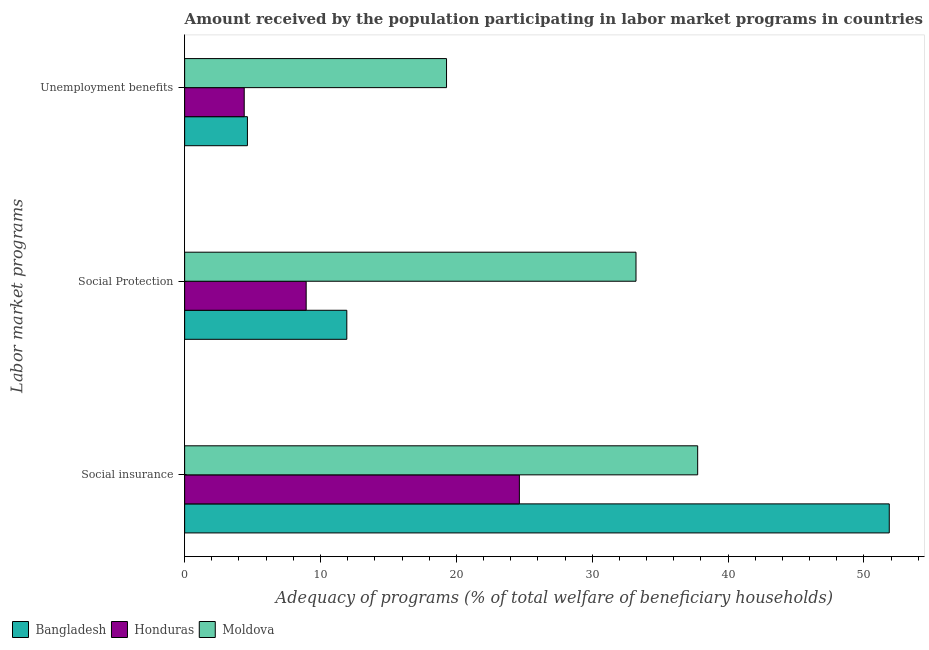How many different coloured bars are there?
Your answer should be compact. 3. Are the number of bars per tick equal to the number of legend labels?
Give a very brief answer. Yes. What is the label of the 2nd group of bars from the top?
Make the answer very short. Social Protection. What is the amount received by the population participating in social insurance programs in Moldova?
Your answer should be compact. 37.76. Across all countries, what is the maximum amount received by the population participating in unemployment benefits programs?
Provide a succinct answer. 19.28. Across all countries, what is the minimum amount received by the population participating in social insurance programs?
Your answer should be very brief. 24.64. In which country was the amount received by the population participating in social protection programs maximum?
Provide a succinct answer. Moldova. In which country was the amount received by the population participating in unemployment benefits programs minimum?
Offer a very short reply. Honduras. What is the total amount received by the population participating in social insurance programs in the graph?
Provide a succinct answer. 114.26. What is the difference between the amount received by the population participating in unemployment benefits programs in Bangladesh and that in Moldova?
Your answer should be very brief. -14.66. What is the difference between the amount received by the population participating in unemployment benefits programs in Honduras and the amount received by the population participating in social protection programs in Bangladesh?
Offer a very short reply. -7.55. What is the average amount received by the population participating in unemployment benefits programs per country?
Offer a terse response. 9.43. What is the difference between the amount received by the population participating in social insurance programs and amount received by the population participating in social protection programs in Moldova?
Provide a succinct answer. 4.54. In how many countries, is the amount received by the population participating in unemployment benefits programs greater than 38 %?
Give a very brief answer. 0. What is the ratio of the amount received by the population participating in unemployment benefits programs in Bangladesh to that in Honduras?
Provide a succinct answer. 1.05. Is the amount received by the population participating in unemployment benefits programs in Honduras less than that in Bangladesh?
Your response must be concise. Yes. Is the difference between the amount received by the population participating in unemployment benefits programs in Bangladesh and Moldova greater than the difference between the amount received by the population participating in social protection programs in Bangladesh and Moldova?
Provide a short and direct response. Yes. What is the difference between the highest and the second highest amount received by the population participating in social protection programs?
Keep it short and to the point. 21.28. What is the difference between the highest and the lowest amount received by the population participating in social insurance programs?
Provide a short and direct response. 27.22. Is it the case that in every country, the sum of the amount received by the population participating in social insurance programs and amount received by the population participating in social protection programs is greater than the amount received by the population participating in unemployment benefits programs?
Keep it short and to the point. Yes. How many bars are there?
Offer a terse response. 9. What is the difference between two consecutive major ticks on the X-axis?
Offer a terse response. 10. Are the values on the major ticks of X-axis written in scientific E-notation?
Offer a very short reply. No. Does the graph contain any zero values?
Your answer should be very brief. No. Where does the legend appear in the graph?
Offer a very short reply. Bottom left. How many legend labels are there?
Make the answer very short. 3. How are the legend labels stacked?
Provide a short and direct response. Horizontal. What is the title of the graph?
Ensure brevity in your answer.  Amount received by the population participating in labor market programs in countries. What is the label or title of the X-axis?
Keep it short and to the point. Adequacy of programs (% of total welfare of beneficiary households). What is the label or title of the Y-axis?
Offer a terse response. Labor market programs. What is the Adequacy of programs (% of total welfare of beneficiary households) in Bangladesh in Social insurance?
Provide a short and direct response. 51.86. What is the Adequacy of programs (% of total welfare of beneficiary households) in Honduras in Social insurance?
Offer a very short reply. 24.64. What is the Adequacy of programs (% of total welfare of beneficiary households) in Moldova in Social insurance?
Provide a short and direct response. 37.76. What is the Adequacy of programs (% of total welfare of beneficiary households) of Bangladesh in Social Protection?
Your answer should be compact. 11.94. What is the Adequacy of programs (% of total welfare of beneficiary households) in Honduras in Social Protection?
Provide a short and direct response. 8.94. What is the Adequacy of programs (% of total welfare of beneficiary households) of Moldova in Social Protection?
Offer a terse response. 33.22. What is the Adequacy of programs (% of total welfare of beneficiary households) in Bangladesh in Unemployment benefits?
Your response must be concise. 4.62. What is the Adequacy of programs (% of total welfare of beneficiary households) of Honduras in Unemployment benefits?
Make the answer very short. 4.39. What is the Adequacy of programs (% of total welfare of beneficiary households) of Moldova in Unemployment benefits?
Provide a succinct answer. 19.28. Across all Labor market programs, what is the maximum Adequacy of programs (% of total welfare of beneficiary households) in Bangladesh?
Give a very brief answer. 51.86. Across all Labor market programs, what is the maximum Adequacy of programs (% of total welfare of beneficiary households) of Honduras?
Offer a very short reply. 24.64. Across all Labor market programs, what is the maximum Adequacy of programs (% of total welfare of beneficiary households) of Moldova?
Ensure brevity in your answer.  37.76. Across all Labor market programs, what is the minimum Adequacy of programs (% of total welfare of beneficiary households) of Bangladesh?
Ensure brevity in your answer.  4.62. Across all Labor market programs, what is the minimum Adequacy of programs (% of total welfare of beneficiary households) in Honduras?
Your response must be concise. 4.39. Across all Labor market programs, what is the minimum Adequacy of programs (% of total welfare of beneficiary households) of Moldova?
Ensure brevity in your answer.  19.28. What is the total Adequacy of programs (% of total welfare of beneficiary households) of Bangladesh in the graph?
Your response must be concise. 68.42. What is the total Adequacy of programs (% of total welfare of beneficiary households) in Honduras in the graph?
Keep it short and to the point. 37.97. What is the total Adequacy of programs (% of total welfare of beneficiary households) in Moldova in the graph?
Keep it short and to the point. 90.26. What is the difference between the Adequacy of programs (% of total welfare of beneficiary households) of Bangladesh in Social insurance and that in Social Protection?
Provide a succinct answer. 39.92. What is the difference between the Adequacy of programs (% of total welfare of beneficiary households) of Honduras in Social insurance and that in Social Protection?
Your response must be concise. 15.69. What is the difference between the Adequacy of programs (% of total welfare of beneficiary households) in Moldova in Social insurance and that in Social Protection?
Provide a succinct answer. 4.54. What is the difference between the Adequacy of programs (% of total welfare of beneficiary households) in Bangladesh in Social insurance and that in Unemployment benefits?
Ensure brevity in your answer.  47.24. What is the difference between the Adequacy of programs (% of total welfare of beneficiary households) of Honduras in Social insurance and that in Unemployment benefits?
Offer a very short reply. 20.25. What is the difference between the Adequacy of programs (% of total welfare of beneficiary households) in Moldova in Social insurance and that in Unemployment benefits?
Provide a short and direct response. 18.48. What is the difference between the Adequacy of programs (% of total welfare of beneficiary households) of Bangladesh in Social Protection and that in Unemployment benefits?
Ensure brevity in your answer.  7.32. What is the difference between the Adequacy of programs (% of total welfare of beneficiary households) of Honduras in Social Protection and that in Unemployment benefits?
Offer a very short reply. 4.56. What is the difference between the Adequacy of programs (% of total welfare of beneficiary households) in Moldova in Social Protection and that in Unemployment benefits?
Make the answer very short. 13.95. What is the difference between the Adequacy of programs (% of total welfare of beneficiary households) in Bangladesh in Social insurance and the Adequacy of programs (% of total welfare of beneficiary households) in Honduras in Social Protection?
Your response must be concise. 42.92. What is the difference between the Adequacy of programs (% of total welfare of beneficiary households) in Bangladesh in Social insurance and the Adequacy of programs (% of total welfare of beneficiary households) in Moldova in Social Protection?
Provide a succinct answer. 18.64. What is the difference between the Adequacy of programs (% of total welfare of beneficiary households) in Honduras in Social insurance and the Adequacy of programs (% of total welfare of beneficiary households) in Moldova in Social Protection?
Ensure brevity in your answer.  -8.58. What is the difference between the Adequacy of programs (% of total welfare of beneficiary households) of Bangladesh in Social insurance and the Adequacy of programs (% of total welfare of beneficiary households) of Honduras in Unemployment benefits?
Offer a terse response. 47.48. What is the difference between the Adequacy of programs (% of total welfare of beneficiary households) in Bangladesh in Social insurance and the Adequacy of programs (% of total welfare of beneficiary households) in Moldova in Unemployment benefits?
Your answer should be very brief. 32.59. What is the difference between the Adequacy of programs (% of total welfare of beneficiary households) of Honduras in Social insurance and the Adequacy of programs (% of total welfare of beneficiary households) of Moldova in Unemployment benefits?
Your response must be concise. 5.36. What is the difference between the Adequacy of programs (% of total welfare of beneficiary households) of Bangladesh in Social Protection and the Adequacy of programs (% of total welfare of beneficiary households) of Honduras in Unemployment benefits?
Offer a very short reply. 7.55. What is the difference between the Adequacy of programs (% of total welfare of beneficiary households) of Bangladesh in Social Protection and the Adequacy of programs (% of total welfare of beneficiary households) of Moldova in Unemployment benefits?
Your answer should be compact. -7.34. What is the difference between the Adequacy of programs (% of total welfare of beneficiary households) in Honduras in Social Protection and the Adequacy of programs (% of total welfare of beneficiary households) in Moldova in Unemployment benefits?
Give a very brief answer. -10.33. What is the average Adequacy of programs (% of total welfare of beneficiary households) in Bangladesh per Labor market programs?
Provide a succinct answer. 22.81. What is the average Adequacy of programs (% of total welfare of beneficiary households) of Honduras per Labor market programs?
Keep it short and to the point. 12.66. What is the average Adequacy of programs (% of total welfare of beneficiary households) of Moldova per Labor market programs?
Give a very brief answer. 30.09. What is the difference between the Adequacy of programs (% of total welfare of beneficiary households) of Bangladesh and Adequacy of programs (% of total welfare of beneficiary households) of Honduras in Social insurance?
Provide a succinct answer. 27.22. What is the difference between the Adequacy of programs (% of total welfare of beneficiary households) of Bangladesh and Adequacy of programs (% of total welfare of beneficiary households) of Moldova in Social insurance?
Your response must be concise. 14.1. What is the difference between the Adequacy of programs (% of total welfare of beneficiary households) in Honduras and Adequacy of programs (% of total welfare of beneficiary households) in Moldova in Social insurance?
Provide a short and direct response. -13.12. What is the difference between the Adequacy of programs (% of total welfare of beneficiary households) in Bangladesh and Adequacy of programs (% of total welfare of beneficiary households) in Honduras in Social Protection?
Offer a very short reply. 2.99. What is the difference between the Adequacy of programs (% of total welfare of beneficiary households) of Bangladesh and Adequacy of programs (% of total welfare of beneficiary households) of Moldova in Social Protection?
Keep it short and to the point. -21.28. What is the difference between the Adequacy of programs (% of total welfare of beneficiary households) of Honduras and Adequacy of programs (% of total welfare of beneficiary households) of Moldova in Social Protection?
Make the answer very short. -24.28. What is the difference between the Adequacy of programs (% of total welfare of beneficiary households) of Bangladesh and Adequacy of programs (% of total welfare of beneficiary households) of Honduras in Unemployment benefits?
Offer a very short reply. 0.23. What is the difference between the Adequacy of programs (% of total welfare of beneficiary households) in Bangladesh and Adequacy of programs (% of total welfare of beneficiary households) in Moldova in Unemployment benefits?
Your answer should be compact. -14.66. What is the difference between the Adequacy of programs (% of total welfare of beneficiary households) in Honduras and Adequacy of programs (% of total welfare of beneficiary households) in Moldova in Unemployment benefits?
Ensure brevity in your answer.  -14.89. What is the ratio of the Adequacy of programs (% of total welfare of beneficiary households) in Bangladesh in Social insurance to that in Social Protection?
Offer a terse response. 4.34. What is the ratio of the Adequacy of programs (% of total welfare of beneficiary households) in Honduras in Social insurance to that in Social Protection?
Give a very brief answer. 2.75. What is the ratio of the Adequacy of programs (% of total welfare of beneficiary households) of Moldova in Social insurance to that in Social Protection?
Your answer should be very brief. 1.14. What is the ratio of the Adequacy of programs (% of total welfare of beneficiary households) of Bangladesh in Social insurance to that in Unemployment benefits?
Give a very brief answer. 11.22. What is the ratio of the Adequacy of programs (% of total welfare of beneficiary households) in Honduras in Social insurance to that in Unemployment benefits?
Your response must be concise. 5.62. What is the ratio of the Adequacy of programs (% of total welfare of beneficiary households) of Moldova in Social insurance to that in Unemployment benefits?
Provide a short and direct response. 1.96. What is the ratio of the Adequacy of programs (% of total welfare of beneficiary households) of Bangladesh in Social Protection to that in Unemployment benefits?
Ensure brevity in your answer.  2.58. What is the ratio of the Adequacy of programs (% of total welfare of beneficiary households) in Honduras in Social Protection to that in Unemployment benefits?
Make the answer very short. 2.04. What is the ratio of the Adequacy of programs (% of total welfare of beneficiary households) in Moldova in Social Protection to that in Unemployment benefits?
Offer a very short reply. 1.72. What is the difference between the highest and the second highest Adequacy of programs (% of total welfare of beneficiary households) in Bangladesh?
Provide a short and direct response. 39.92. What is the difference between the highest and the second highest Adequacy of programs (% of total welfare of beneficiary households) of Honduras?
Give a very brief answer. 15.69. What is the difference between the highest and the second highest Adequacy of programs (% of total welfare of beneficiary households) in Moldova?
Make the answer very short. 4.54. What is the difference between the highest and the lowest Adequacy of programs (% of total welfare of beneficiary households) of Bangladesh?
Provide a succinct answer. 47.24. What is the difference between the highest and the lowest Adequacy of programs (% of total welfare of beneficiary households) of Honduras?
Provide a succinct answer. 20.25. What is the difference between the highest and the lowest Adequacy of programs (% of total welfare of beneficiary households) of Moldova?
Provide a short and direct response. 18.48. 